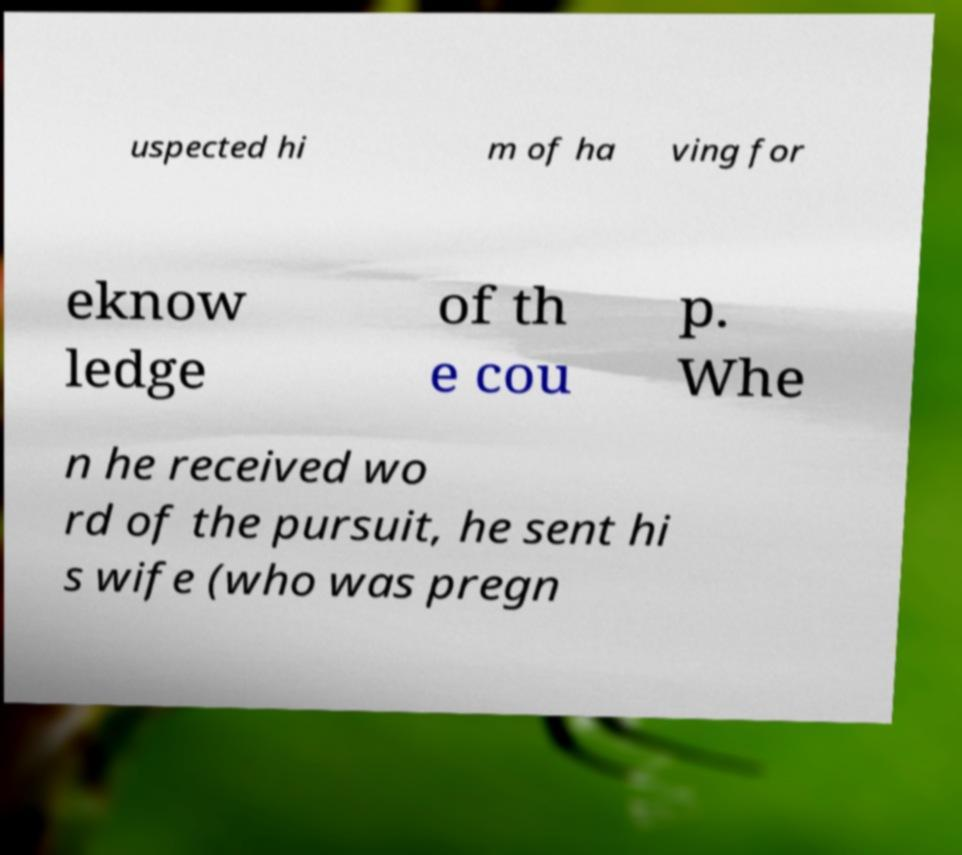There's text embedded in this image that I need extracted. Can you transcribe it verbatim? uspected hi m of ha ving for eknow ledge of th e cou p. Whe n he received wo rd of the pursuit, he sent hi s wife (who was pregn 